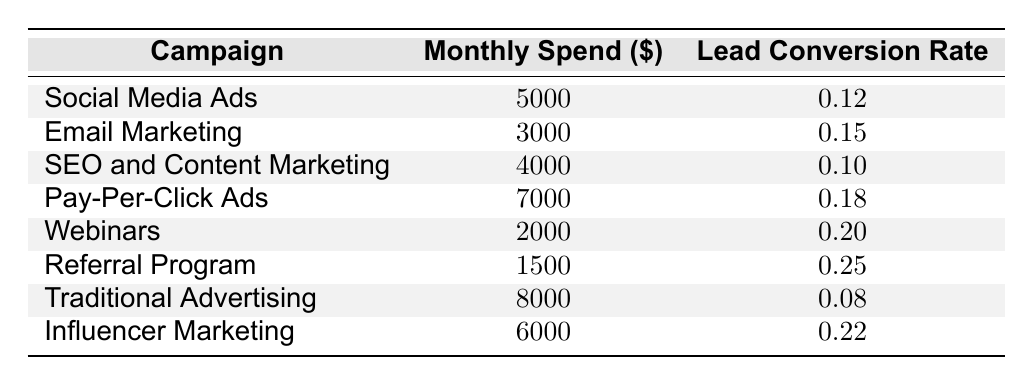What is the lead conversion rate for the Pay-Per-Click Ads campaign? According to the table, Pay-Per-Click Ads has a Lead Conversion Rate of 0.18.
Answer: 0.18 Which campaign has the highest monthly spend? The highest monthly spend is for Traditional Advertising at 8000.
Answer: Traditional Advertising What is the average lead conversion rate across all campaigns? To find the average, sum the lead conversion rates (0.12 + 0.15 + 0.10 + 0.18 + 0.20 + 0.25 + 0.08 + 0.22 = 1.30) and divide by the number of campaigns (8), thus the average is 1.30 / 8 = 0.1625.
Answer: 0.1625 Is the lead conversion rate for Webinars greater than that for Social Media Ads? Webinars has a Lead Conversion Rate of 0.20, while Social Media Ads has a Lead Conversion Rate of 0.12. Since 0.20 is greater than 0.12, the statement is true.
Answer: Yes Which campaign offers both high monthly spending and high lead conversion rates? Among the options, the Pay-Per-Click Ads campaign has a high spend of 7000 and a conversion rate of 0.18, which is significant. By examining the monthly spend and conversion rates, no other campaign reaches similar levels in both categories.
Answer: Pay-Per-Click Ads How much does the Referral Program spend compared to the Influencer Marketing campaign? Referral Program has a Monthly Spend of 1500, while Influencer Marketing spends 6000. The difference is 6000 - 1500 = 4500, with Influencer Marketing spending more.
Answer: Influencer Marketing spends 4500 more Is the average monthly spend of the campaigns over 5000 dollars? The total monthly spend is (5000 + 3000 + 4000 + 7000 + 2000 + 1500 + 8000 + 6000 = 38000) and the average is 38000 / 8 = 4750, which is less than 5000.
Answer: No Which campaign has the lowest conversion rate, and what is it? The campaign with the lowest conversion rate is Traditional Advertising, with a rate of 0.08.
Answer: Traditional Advertising, 0.08 